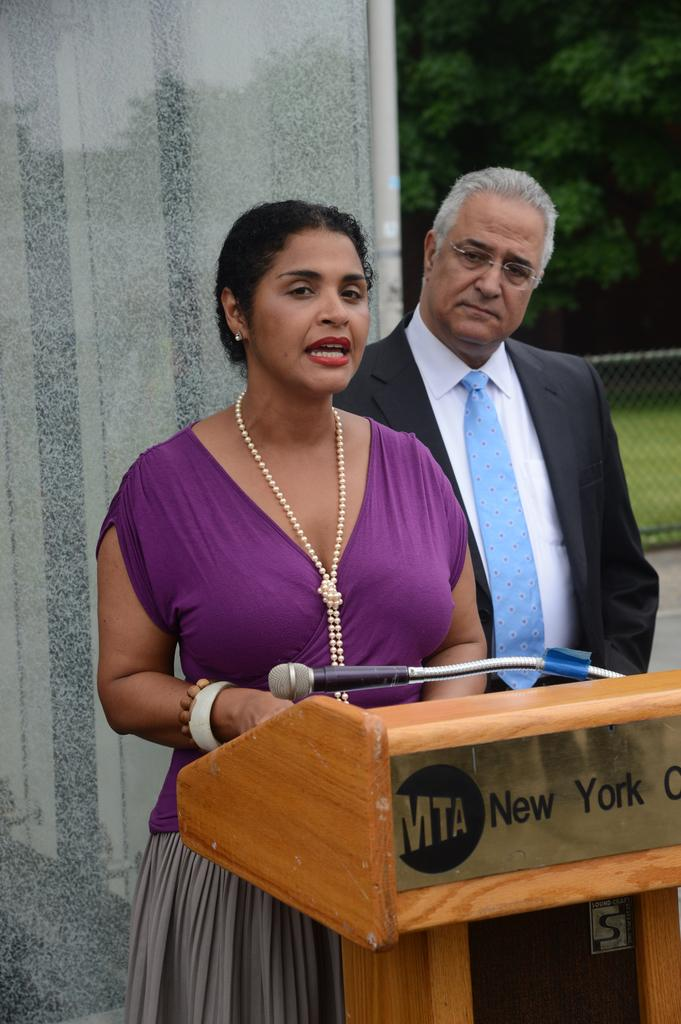How many people are present in the image? There is a man and a woman in the image, making a total of two people. What objects can be seen near the people in the image? There is a podium and a microphone in the image. What is visible in the background of the image? There is a wall, welded wire mesh, and trees in the background of the image. What type of silk is draped over the podium in the image? There is no silk present in the image; the podium is not draped with any fabric. Can you see a road in the image? There is no road visible in the image; the focus is on the people, objects, and background elements mentioned in the facts. 